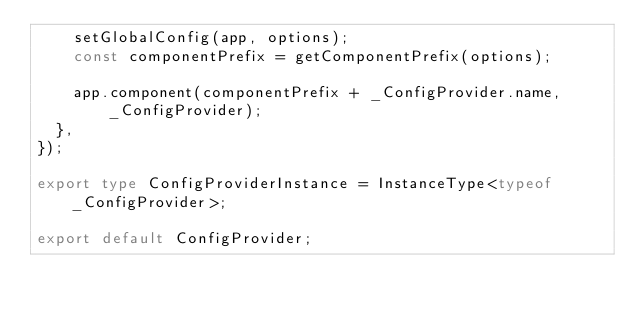<code> <loc_0><loc_0><loc_500><loc_500><_TypeScript_>    setGlobalConfig(app, options);
    const componentPrefix = getComponentPrefix(options);

    app.component(componentPrefix + _ConfigProvider.name, _ConfigProvider);
  },
});

export type ConfigProviderInstance = InstanceType<typeof _ConfigProvider>;

export default ConfigProvider;
</code> 